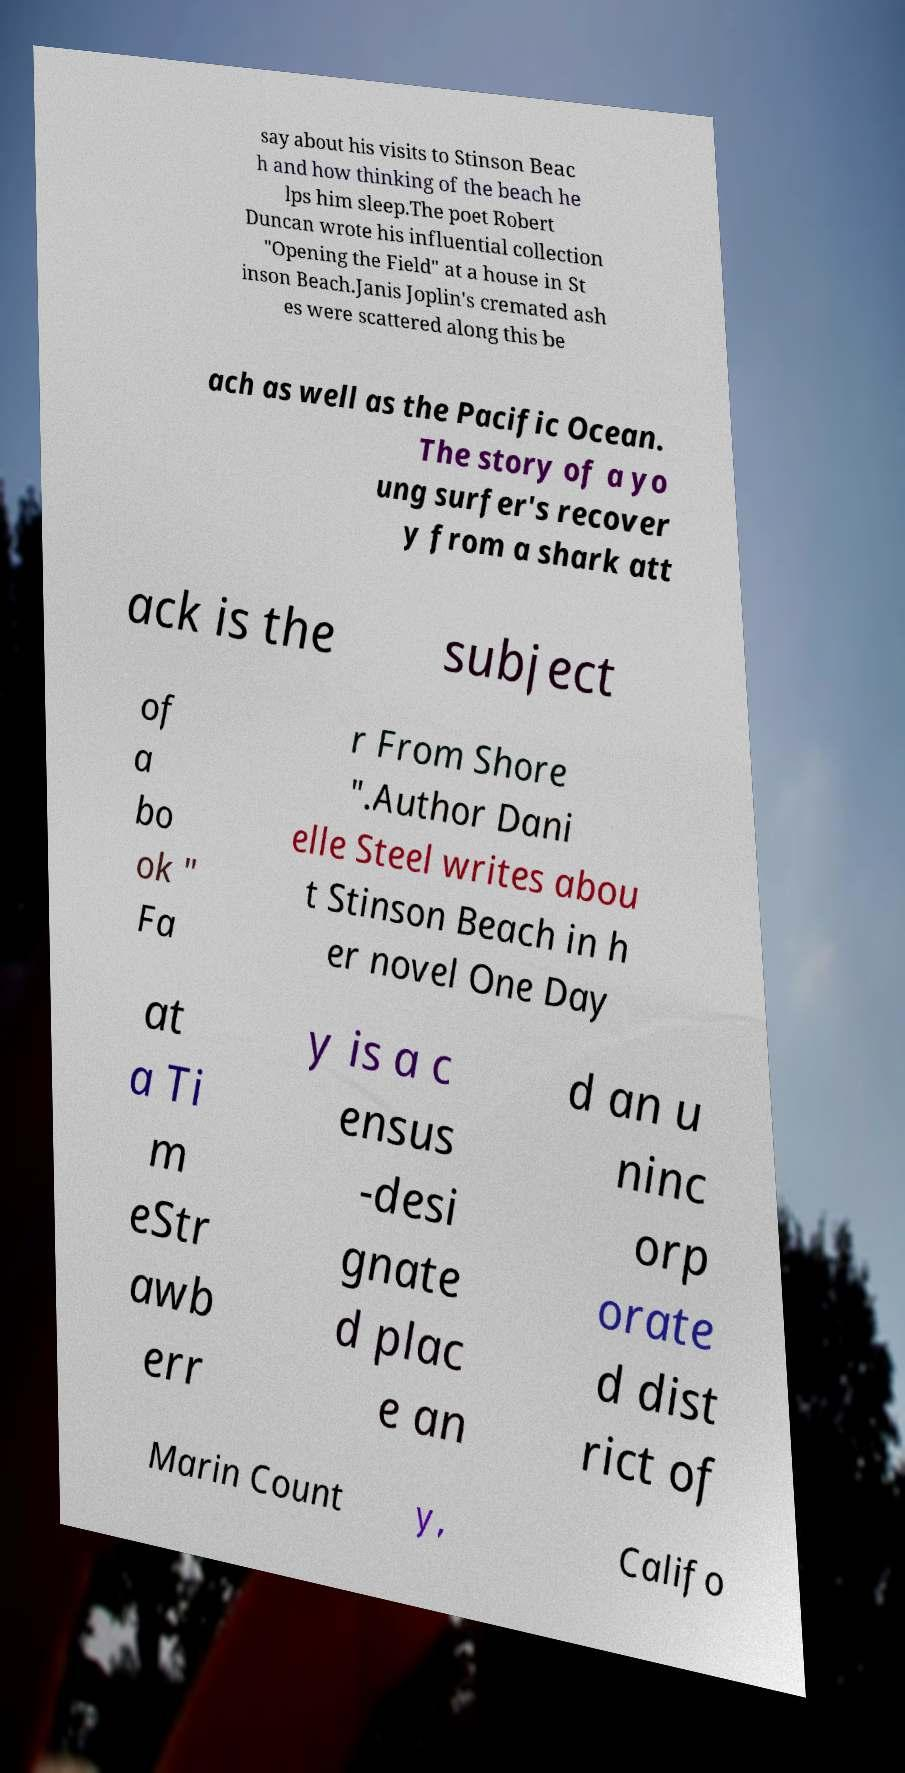What messages or text are displayed in this image? I need them in a readable, typed format. say about his visits to Stinson Beac h and how thinking of the beach he lps him sleep.The poet Robert Duncan wrote his influential collection "Opening the Field" at a house in St inson Beach.Janis Joplin's cremated ash es were scattered along this be ach as well as the Pacific Ocean. The story of a yo ung surfer's recover y from a shark att ack is the subject of a bo ok " Fa r From Shore ".Author Dani elle Steel writes abou t Stinson Beach in h er novel One Day at a Ti m eStr awb err y is a c ensus -desi gnate d plac e an d an u ninc orp orate d dist rict of Marin Count y, Califo 